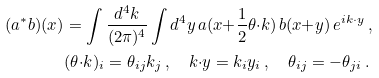Convert formula to latex. <formula><loc_0><loc_0><loc_500><loc_500>( a ^ { * } b ) ( x ) & = \int \frac { d ^ { 4 } k } { ( 2 \pi ) ^ { 4 } } \int d ^ { 4 } y \, a ( x { + } \frac { 1 } { 2 } \theta { \cdot } k ) \, b ( x { + } y ) \, e ^ { i k \cdot y } \, , \\ & ( \theta { \cdot } k ) _ { i } = \theta _ { i j } k _ { j } \, , \quad k { \cdot } y = k _ { i } y _ { i } \, , \quad \theta _ { i j } = - \theta _ { j i } \, .</formula> 